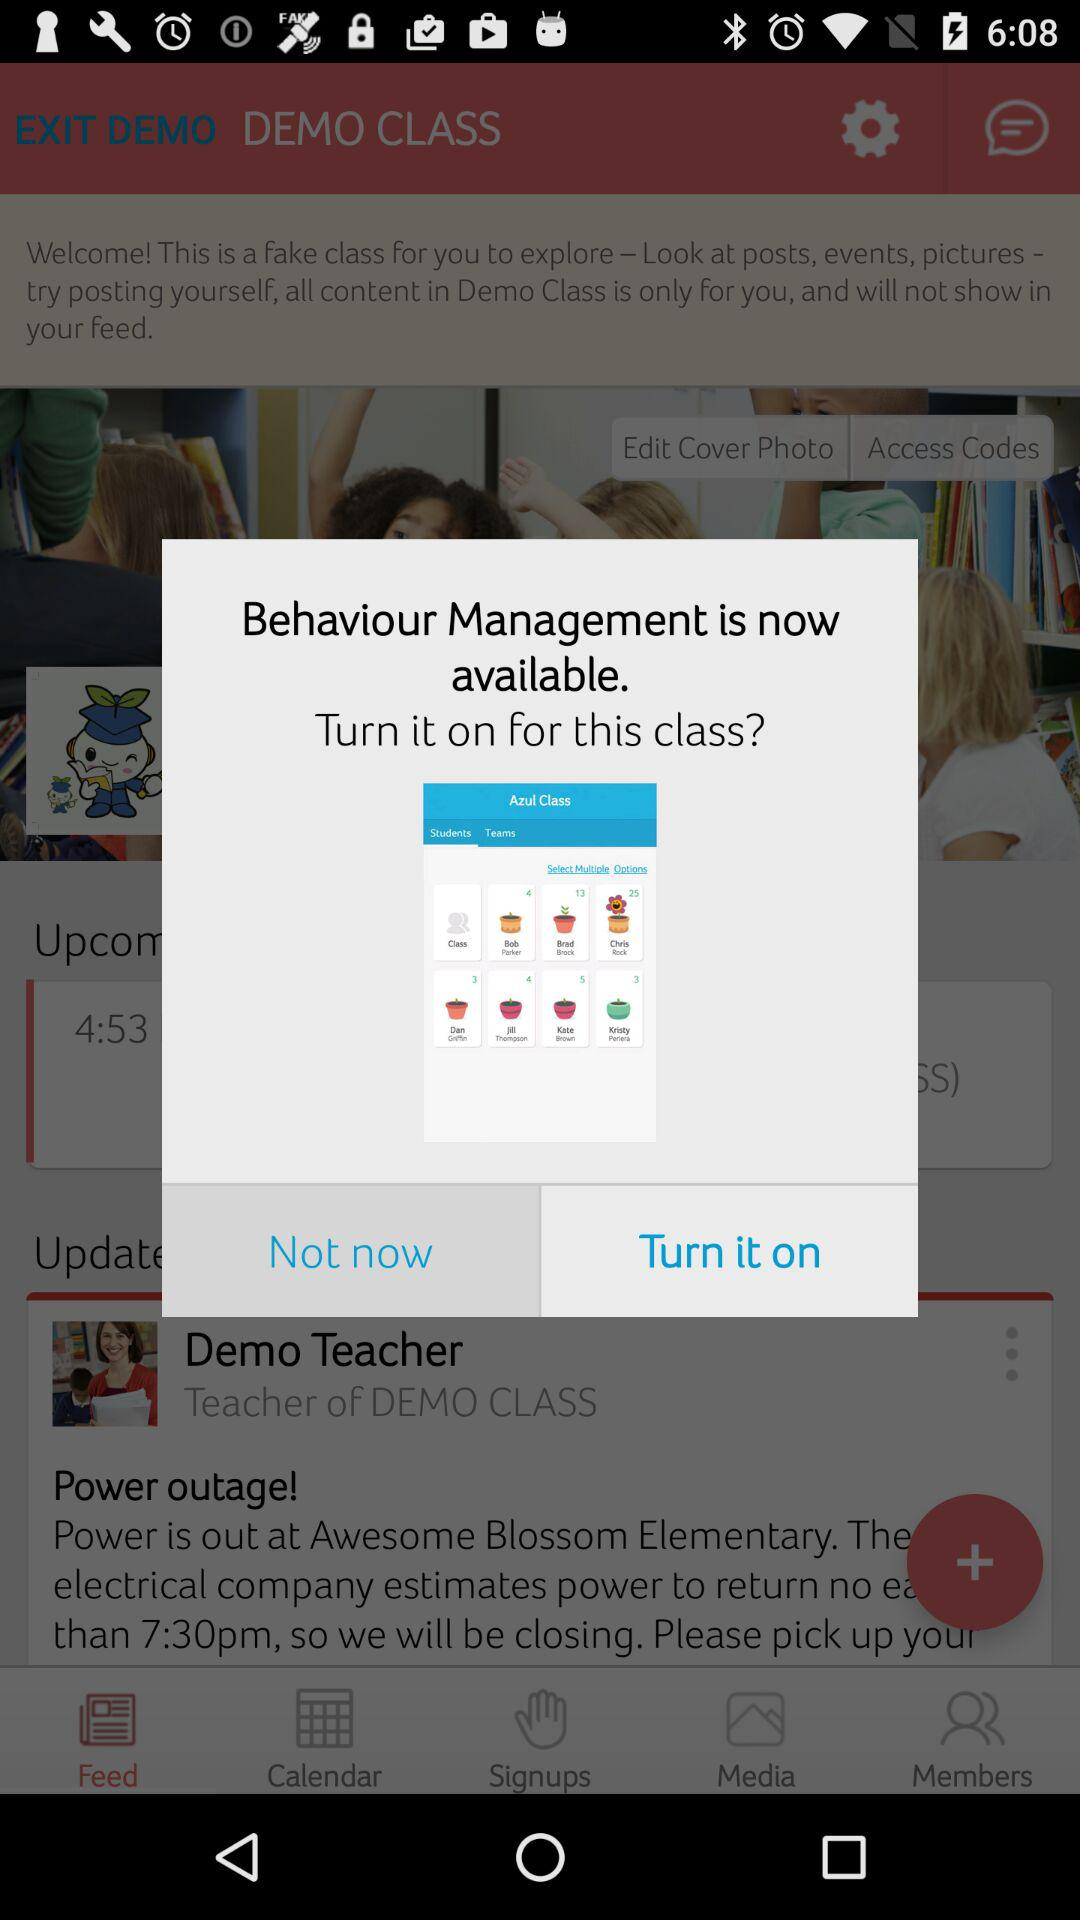What are the given options in the primary role? The given options are "Teacher", "Room Parent" and "PTA Leader". 